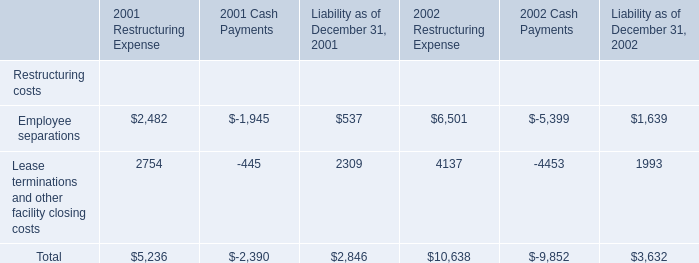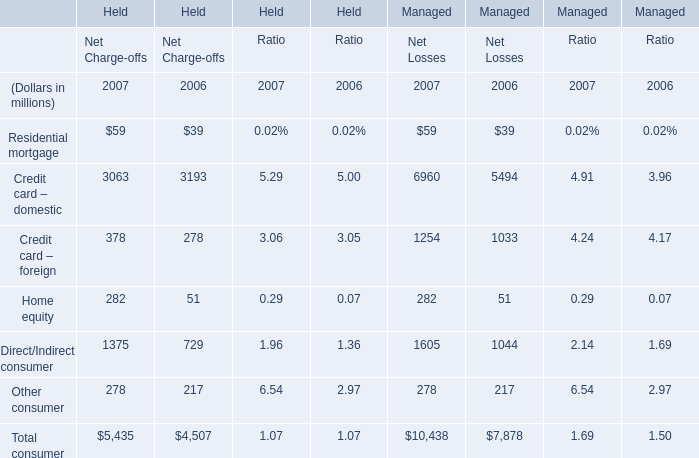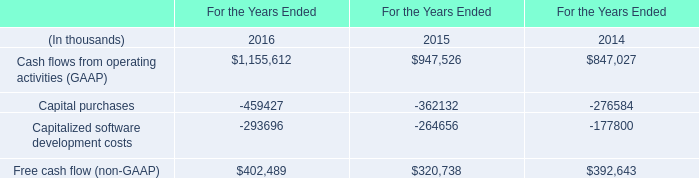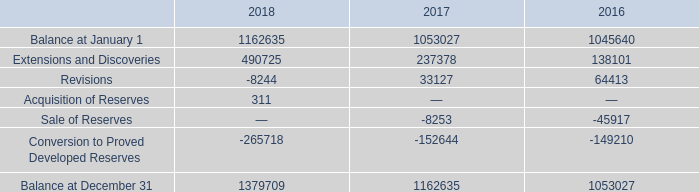How many Total consumer exceed the average of Total consumer in 2007? 
Answer: 1. 